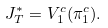Convert formula to latex. <formula><loc_0><loc_0><loc_500><loc_500>\ J _ { T } ^ { * } = V ^ { c } _ { 1 } ( \pi ^ { c } _ { 1 } ) .</formula> 